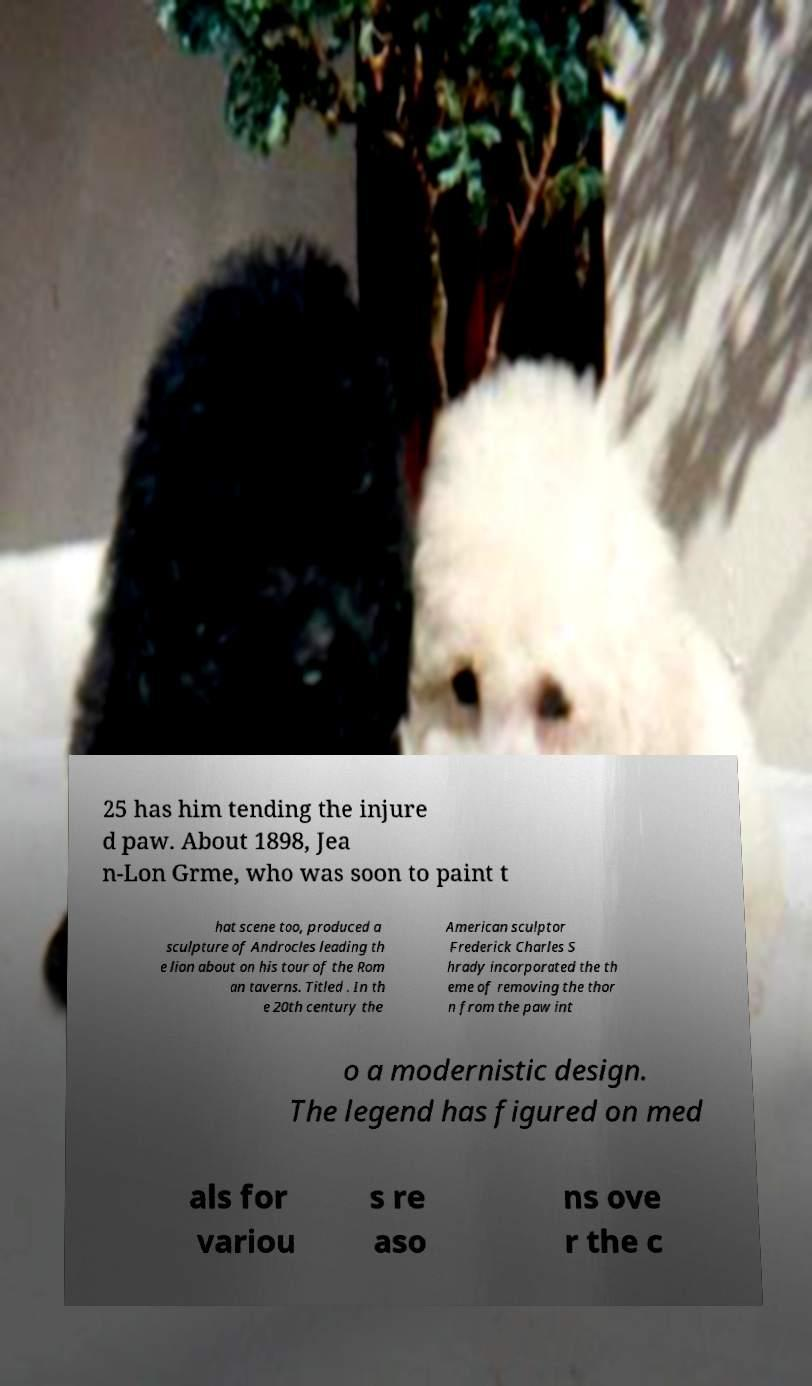For documentation purposes, I need the text within this image transcribed. Could you provide that? 25 has him tending the injure d paw. About 1898, Jea n-Lon Grme, who was soon to paint t hat scene too, produced a sculpture of Androcles leading th e lion about on his tour of the Rom an taverns. Titled . In th e 20th century the American sculptor Frederick Charles S hrady incorporated the th eme of removing the thor n from the paw int o a modernistic design. The legend has figured on med als for variou s re aso ns ove r the c 